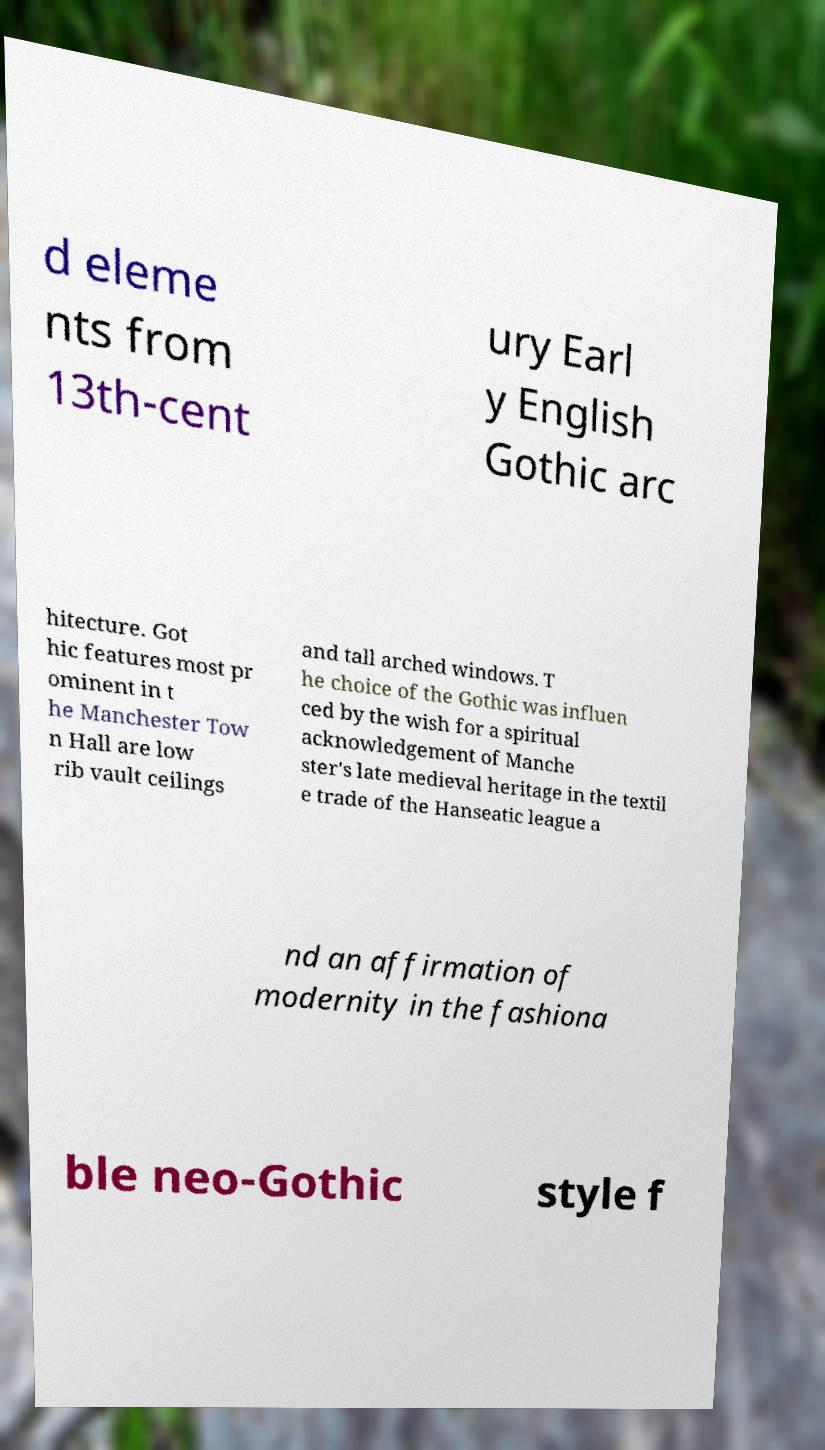For documentation purposes, I need the text within this image transcribed. Could you provide that? d eleme nts from 13th-cent ury Earl y English Gothic arc hitecture. Got hic features most pr ominent in t he Manchester Tow n Hall are low rib vault ceilings and tall arched windows. T he choice of the Gothic was influen ced by the wish for a spiritual acknowledgement of Manche ster's late medieval heritage in the textil e trade of the Hanseatic league a nd an affirmation of modernity in the fashiona ble neo-Gothic style f 